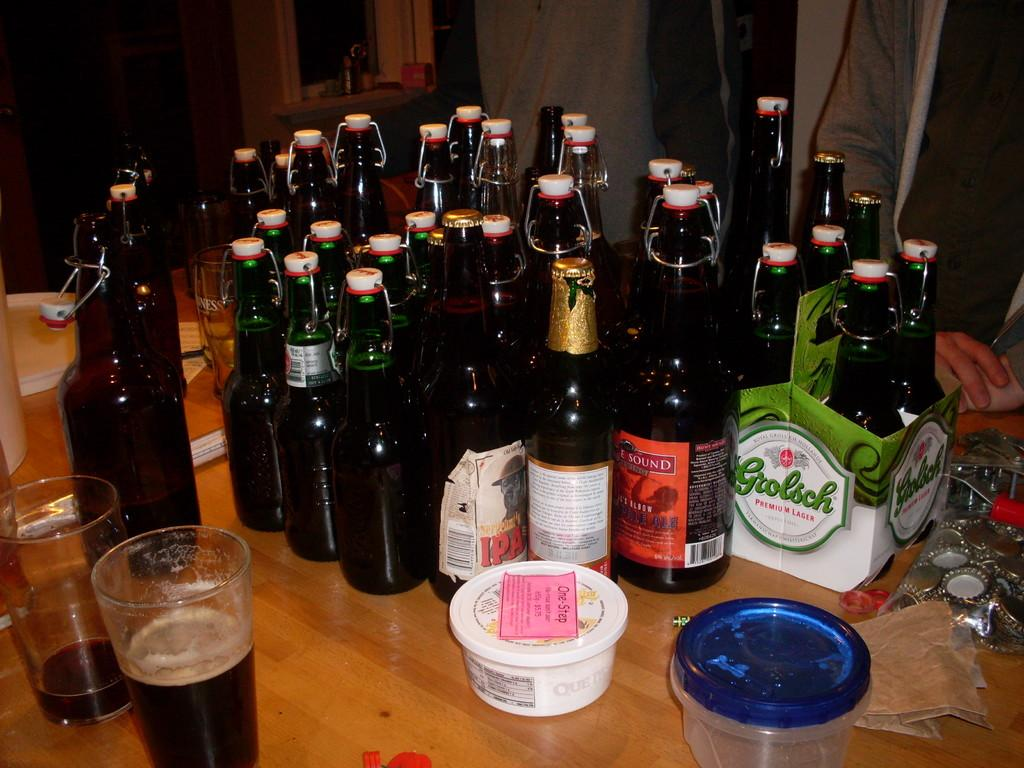<image>
Describe the image concisely. Several bottles of alcohol sit on a table and some are in a green carrier that says grolish on the side. 